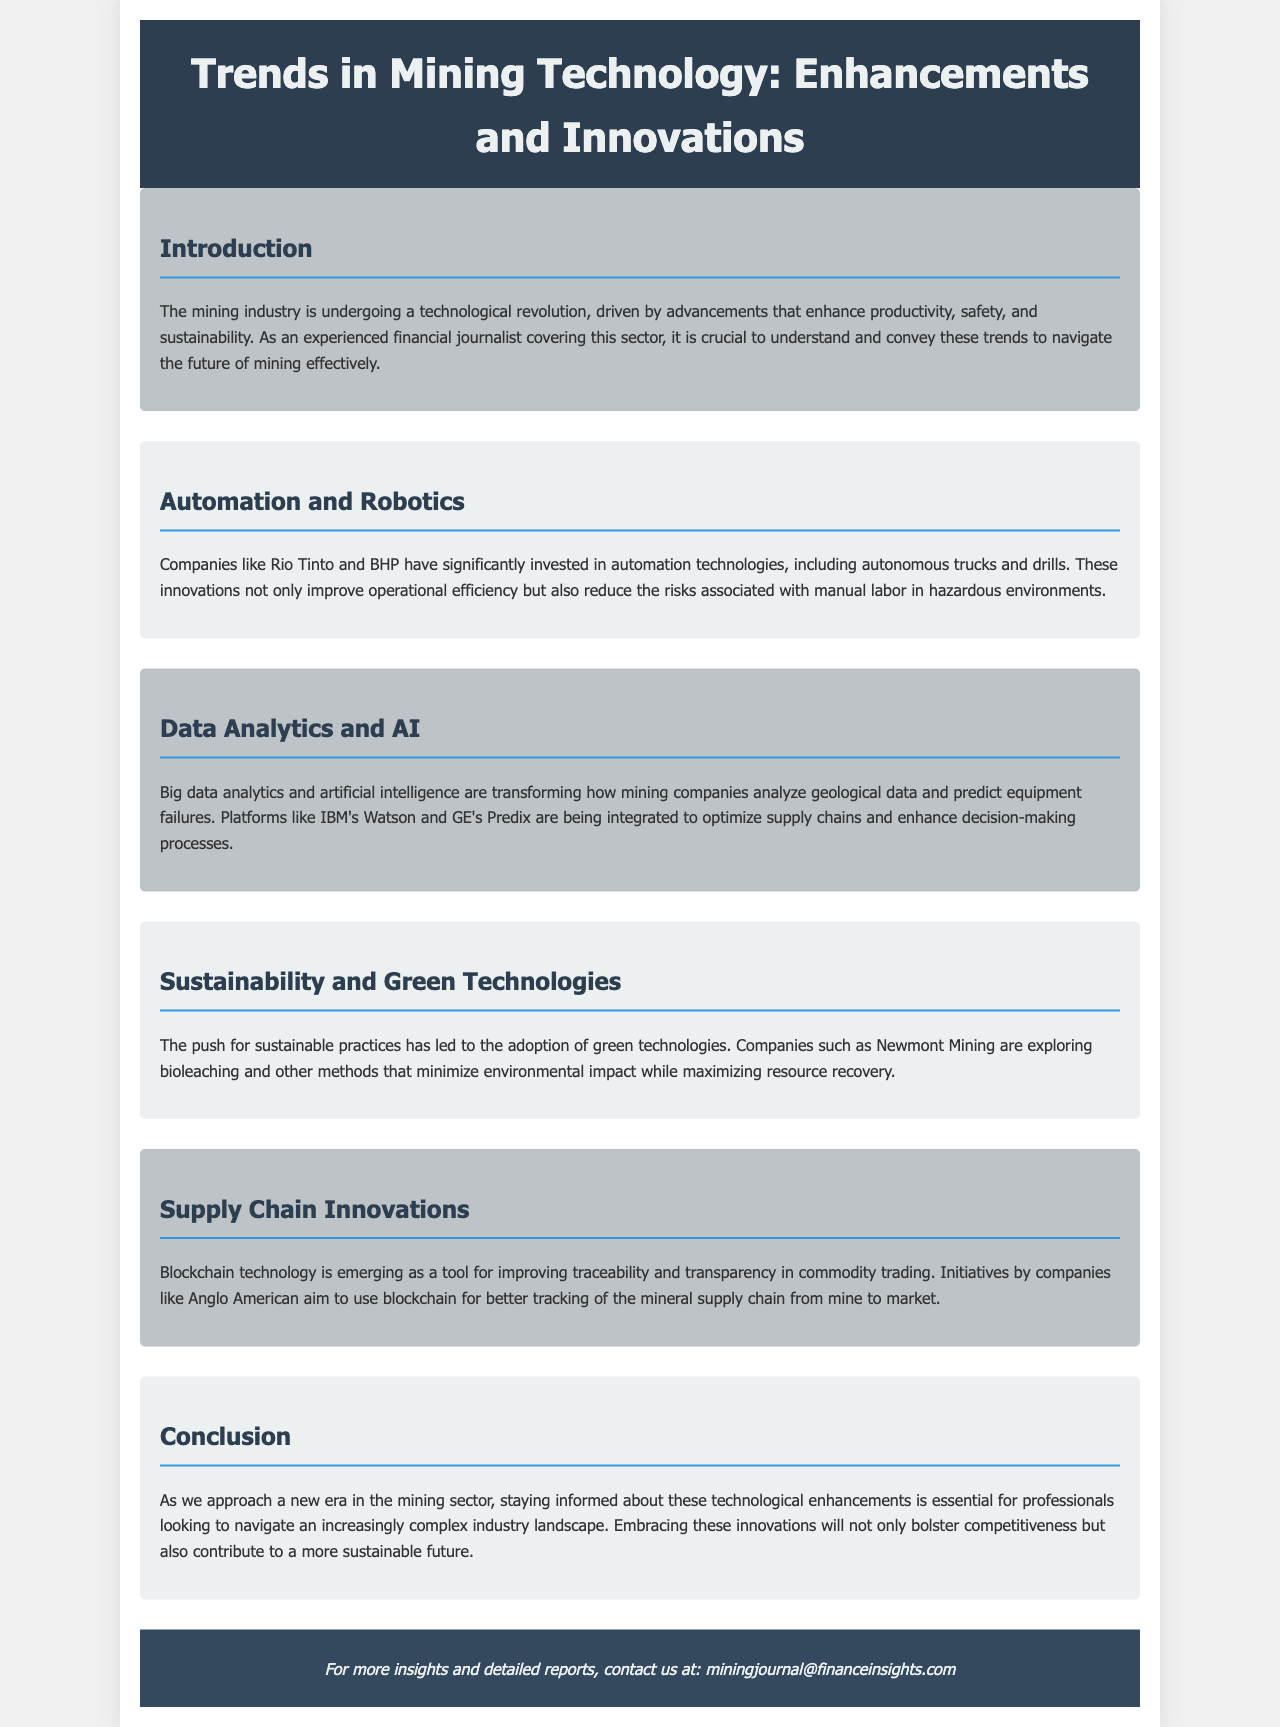What companies have invested in automation technologies? The document mentions that companies like Rio Tinto and BHP have invested in automation technologies.
Answer: Rio Tinto and BHP What technology is being used to enhance decision-making processes? The document lists big data analytics and artificial intelligence as technologies that enhance decision-making processes.
Answer: Big data analytics and artificial intelligence What are Newmont Mining exploring to minimize environmental impact? The document states that Newmont Mining is exploring bioleaching and other methods to minimize environmental impact.
Answer: Bioleaching What role does blockchain technology play in mining? The document indicates that blockchain technology is used for improving traceability and transparency in commodity trading.
Answer: Traceability and transparency What is the primary focus of the brochure? The brochure focuses on trends in mining technology enhancements and innovations that affect productivity, safety, and sustainability.
Answer: Trends in mining technology Why is understanding technological innovations important for professionals in the mining sector? The document highlights that understanding these innovations is essential for navigating an increasingly complex industry landscape.
Answer: To navigate an increasingly complex industry landscape 